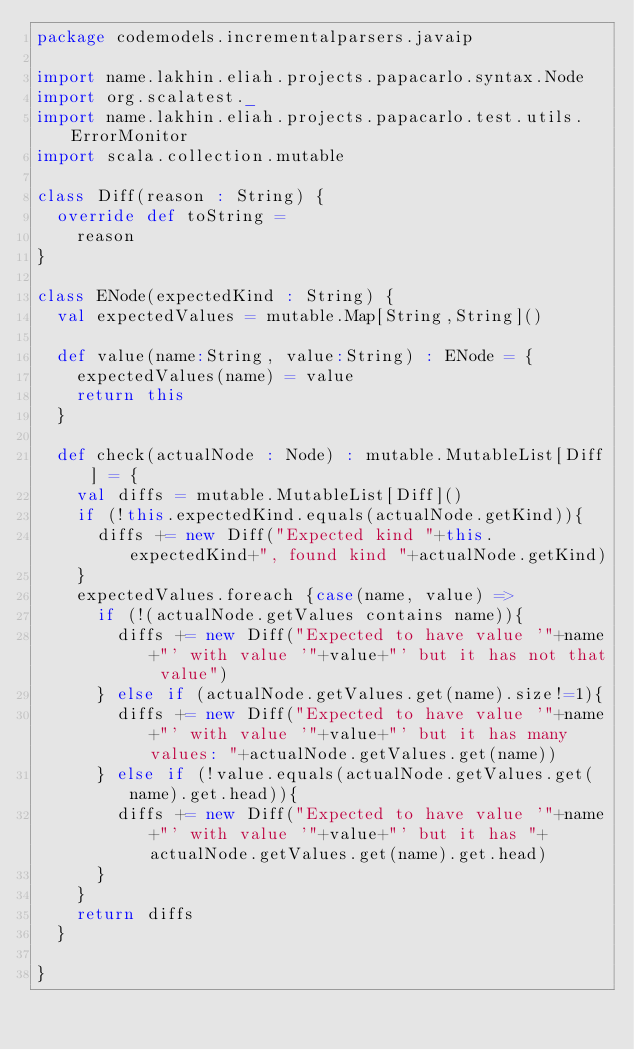<code> <loc_0><loc_0><loc_500><loc_500><_Scala_>package codemodels.incrementalparsers.javaip

import name.lakhin.eliah.projects.papacarlo.syntax.Node
import org.scalatest._
import name.lakhin.eliah.projects.papacarlo.test.utils.ErrorMonitor
import scala.collection.mutable

class Diff(reason : String) {
  override def toString =
    reason
}

class ENode(expectedKind : String) {
  val expectedValues = mutable.Map[String,String]()

  def value(name:String, value:String) : ENode = {
    expectedValues(name) = value
    return this
  }

  def check(actualNode : Node) : mutable.MutableList[Diff] = {
    val diffs = mutable.MutableList[Diff]()
    if (!this.expectedKind.equals(actualNode.getKind)){
      diffs += new Diff("Expected kind "+this.expectedKind+", found kind "+actualNode.getKind)
    }
    expectedValues.foreach {case(name, value) =>
      if (!(actualNode.getValues contains name)){
        diffs += new Diff("Expected to have value '"+name+"' with value '"+value+"' but it has not that value")
      } else if (actualNode.getValues.get(name).size!=1){
        diffs += new Diff("Expected to have value '"+name+"' with value '"+value+"' but it has many values: "+actualNode.getValues.get(name))
      } else if (!value.equals(actualNode.getValues.get(name).get.head)){
        diffs += new Diff("Expected to have value '"+name+"' with value '"+value+"' but it has "+actualNode.getValues.get(name).get.head)
      }
    }
    return diffs
  }

}
</code> 